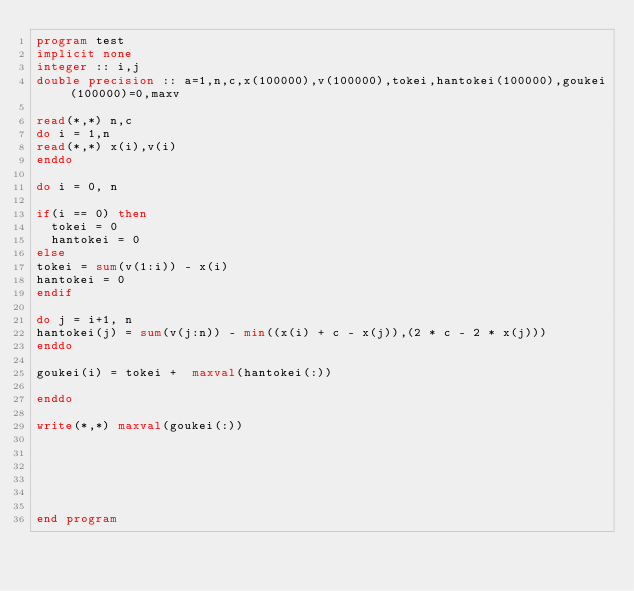<code> <loc_0><loc_0><loc_500><loc_500><_FORTRAN_>program test
implicit none
integer :: i,j
double precision :: a=1,n,c,x(100000),v(100000),tokei,hantokei(100000),goukei(100000)=0,maxv

read(*,*) n,c
do i = 1,n
read(*,*) x(i),v(i)
enddo

do i = 0, n

if(i == 0) then
  tokei = 0
  hantokei = 0
else
tokei = sum(v(1:i)) - x(i)
hantokei = 0
endif

do j = i+1, n
hantokei(j) = sum(v(j:n)) - min((x(i) + c - x(j)),(2 * c - 2 * x(j)))
enddo

goukei(i) = tokei +  maxval(hantokei(:))

enddo

write(*,*) maxval(goukei(:))






end program</code> 